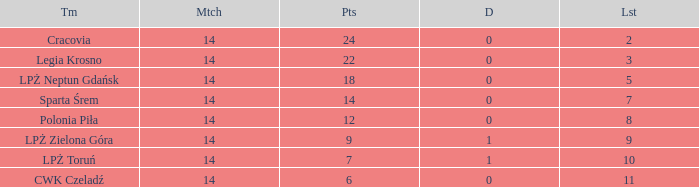What is the lowest points for a match before 14? None. 